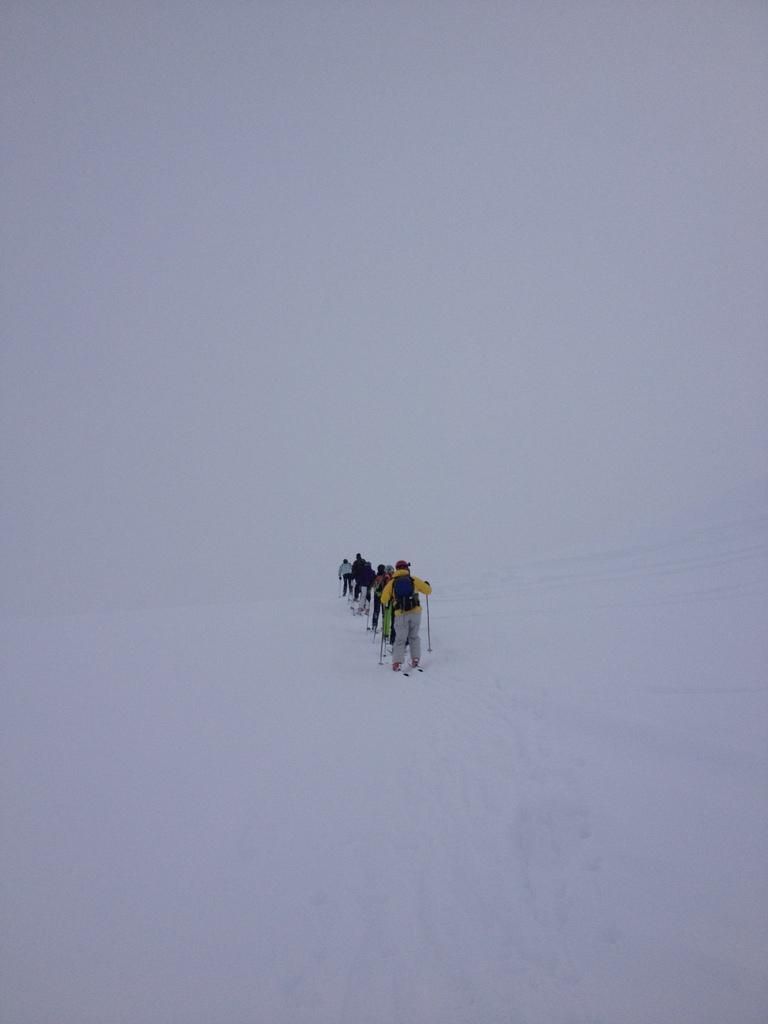Who is present in the image? There are people in the image. What activity are the people engaged in? The people are skiing. On what surface are the people skiing? The skiing is taking place on snow. What type of vessel can be seen in the image? There is no vessel present in the image; it features people skiing on snow. What type of growth can be observed on the skis in the image? There is no growth visible on the skis in the image; the focus is on the people skiing. 